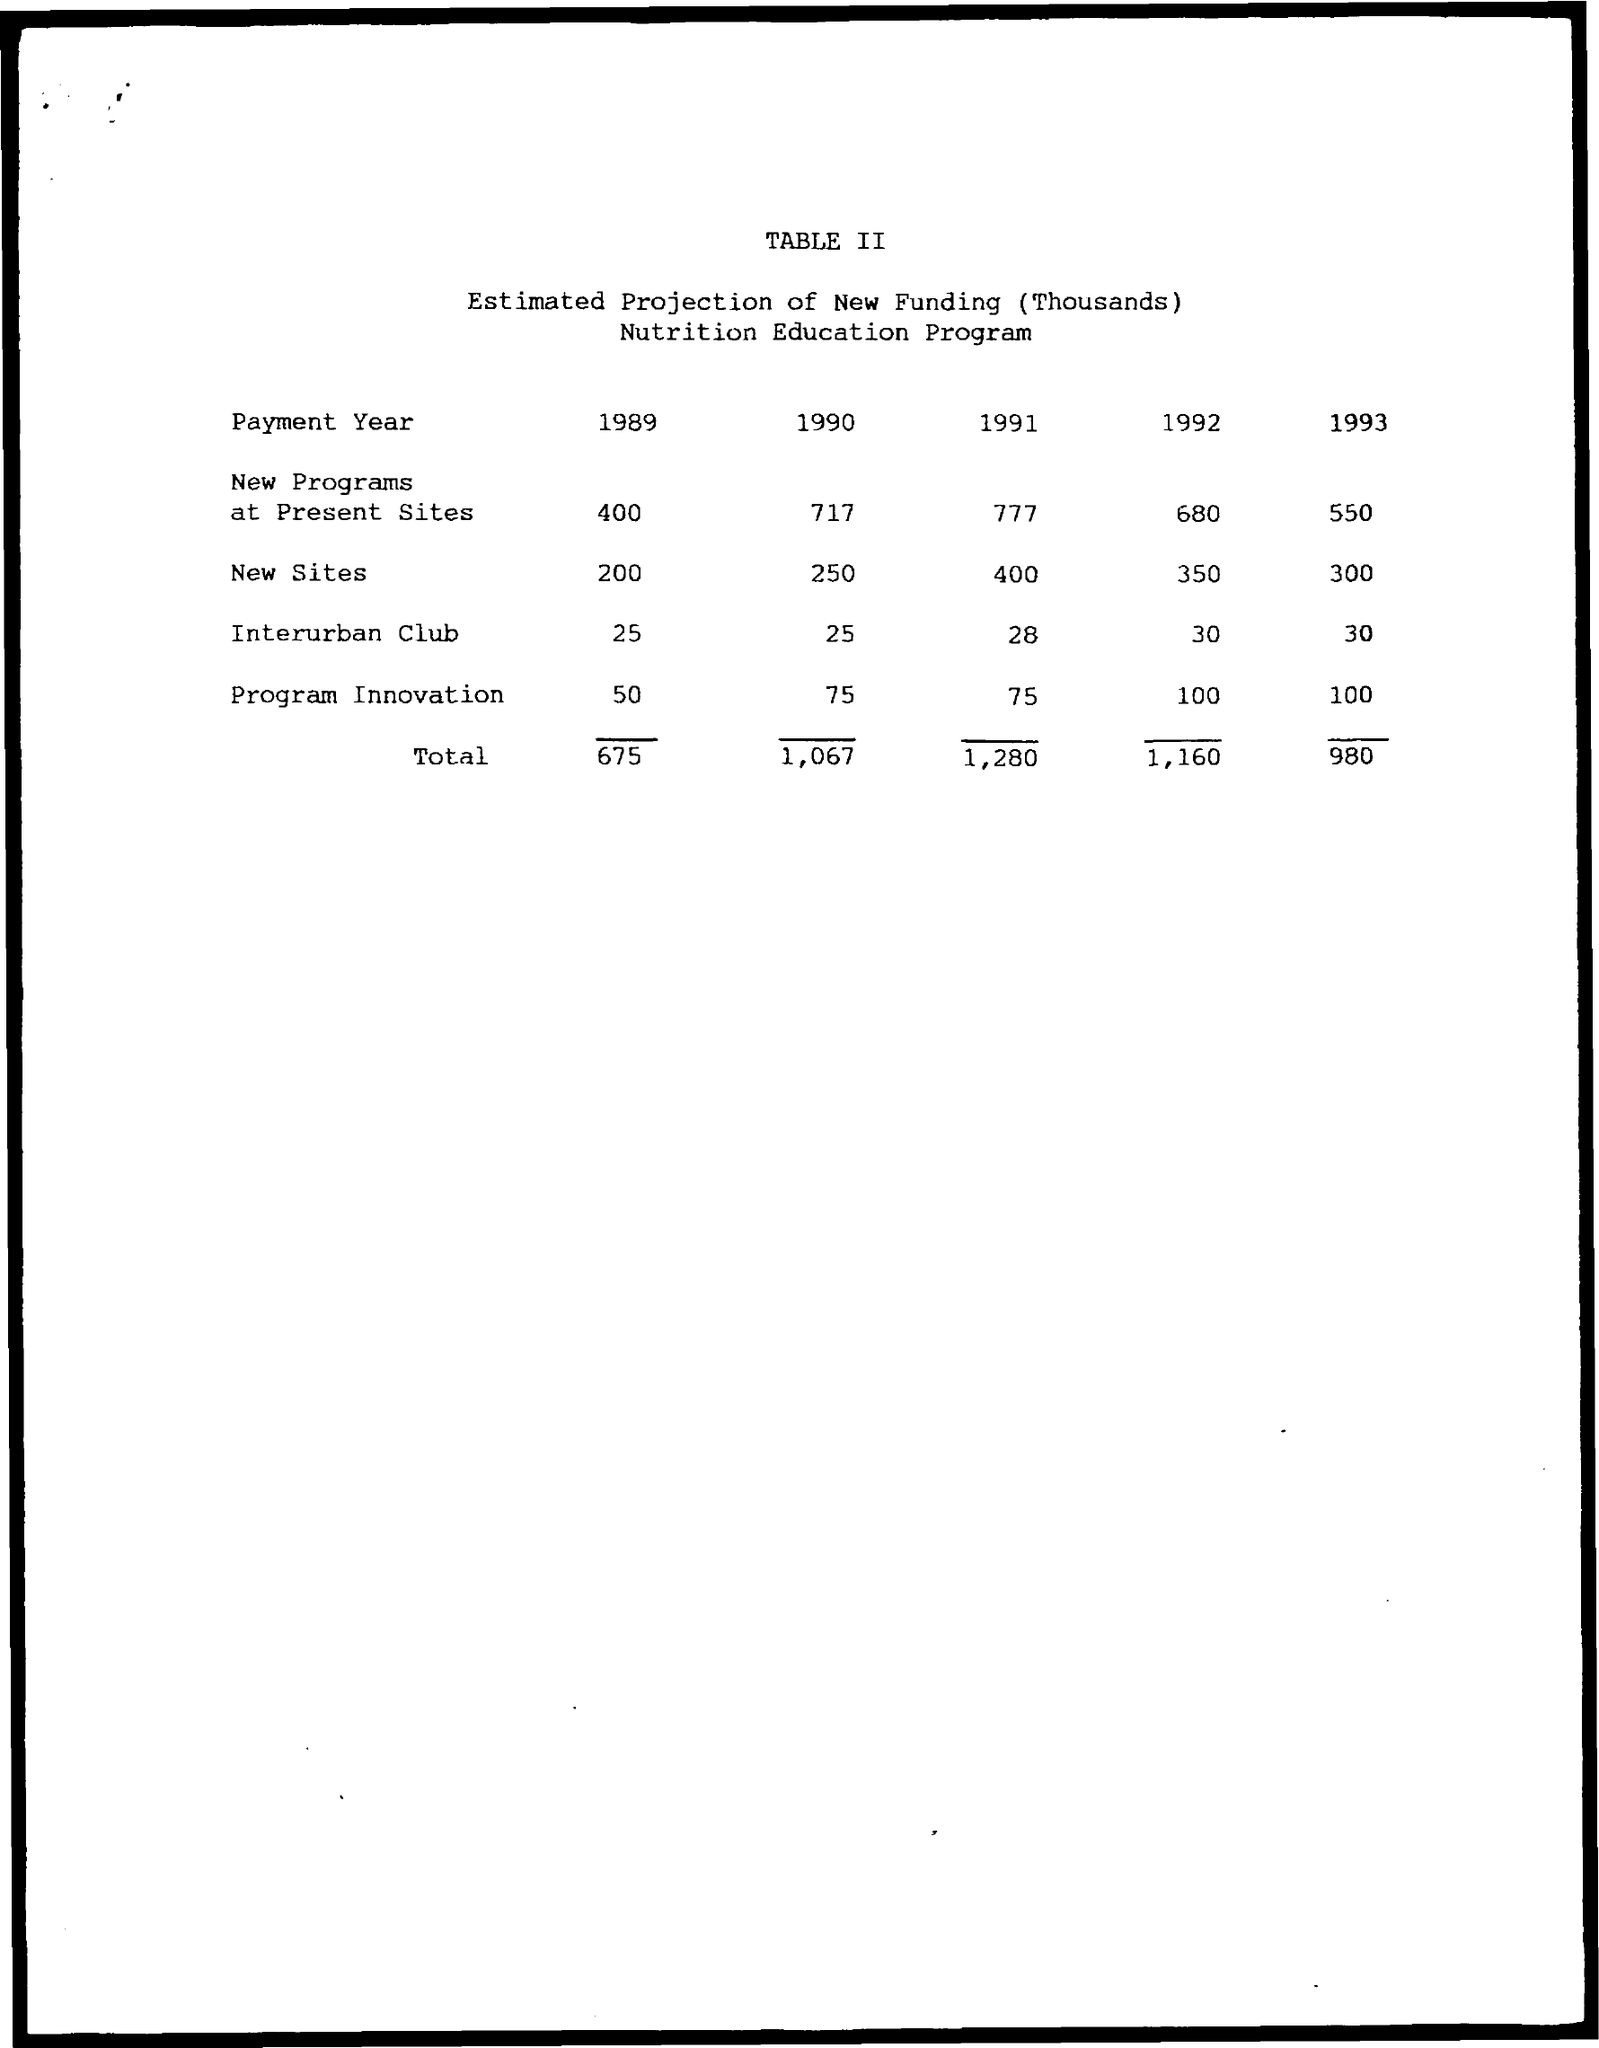Outline some significant characteristics in this image. In the year 1993, the total amount of funding was 980. In the year 1989, the value of New Sites was 200... The value of Interurban Club in the year 1991 was 28. 